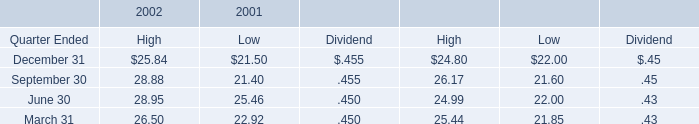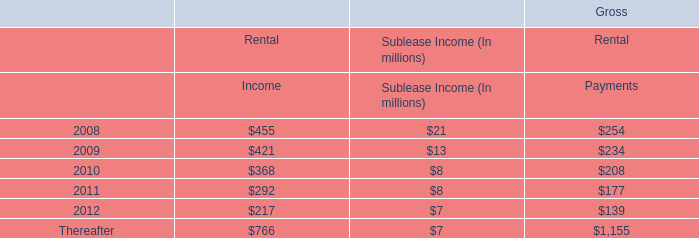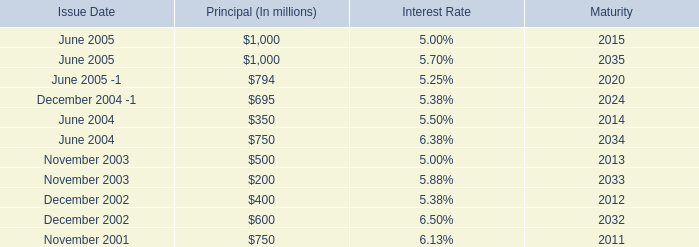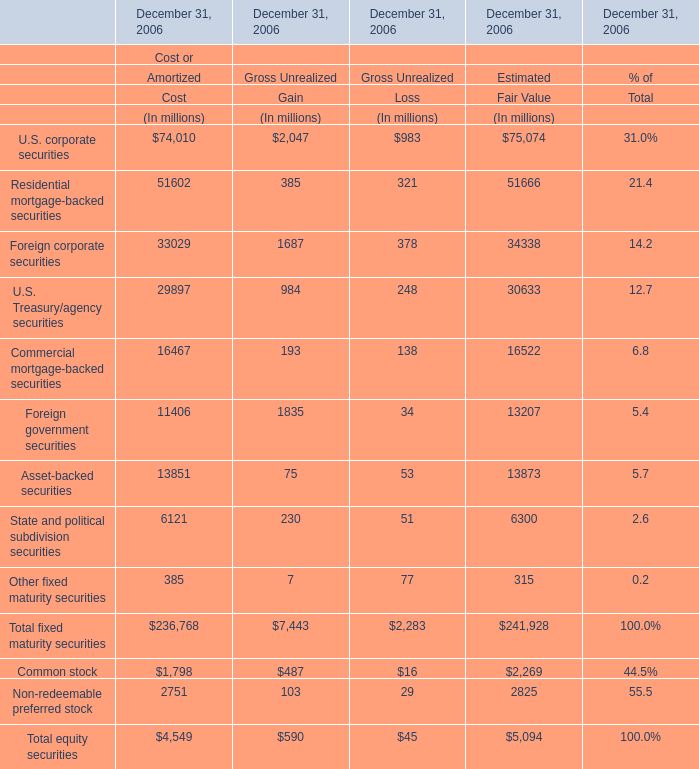What is the difference between the greatest U.S. corporate securities in Cost and Gain ? (in million) 
Computations: (74010 - 2047)
Answer: 71963.0. 